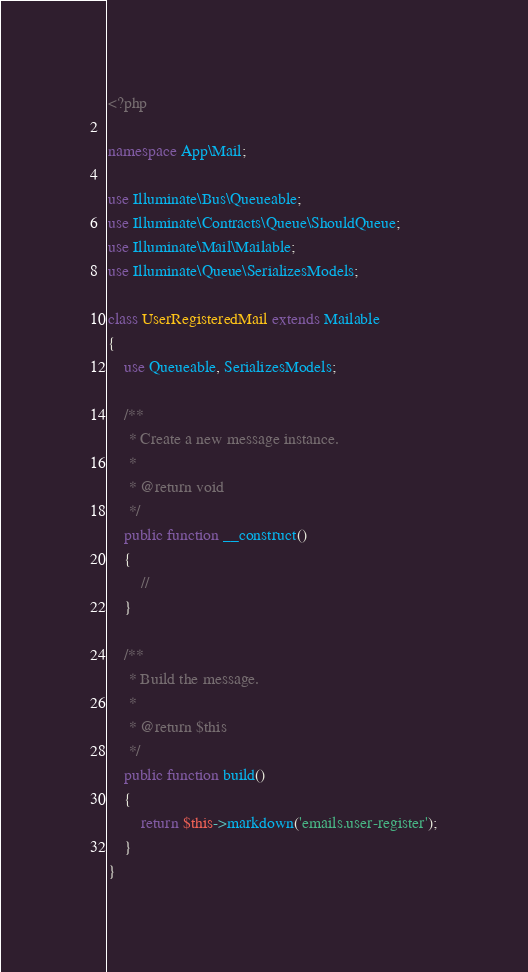Convert code to text. <code><loc_0><loc_0><loc_500><loc_500><_PHP_><?php

namespace App\Mail;

use Illuminate\Bus\Queueable;
use Illuminate\Contracts\Queue\ShouldQueue;
use Illuminate\Mail\Mailable;
use Illuminate\Queue\SerializesModels;

class UserRegisteredMail extends Mailable
{
    use Queueable, SerializesModels;

    /**
     * Create a new message instance.
     *
     * @return void
     */
    public function __construct()
    {
        //
    }

    /**
     * Build the message.
     *
     * @return $this
     */
    public function build()
    {
        return $this->markdown('emails.user-register');
    }
}
</code> 